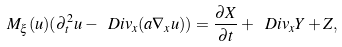Convert formula to latex. <formula><loc_0><loc_0><loc_500><loc_500>M _ { \xi } ( u ) ( \partial _ { t } ^ { 2 } u - \ D i v _ { x } ( a \nabla _ { x } u ) ) = \frac { \partial X } { \partial t } + \ D i v _ { x } Y + Z ,</formula> 